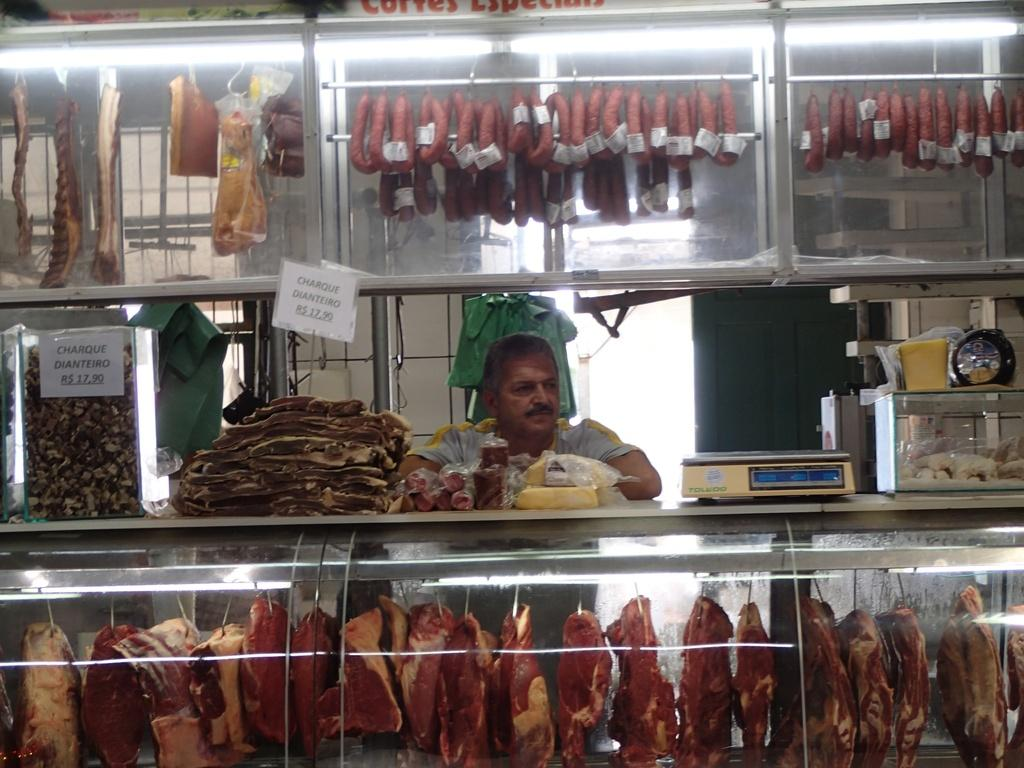Who or what is present in the image? There is a person in the image. What else can be seen in the image besides the person? There is a machine, glass boxes, lights, and meat in the image. Can you describe the machine in the image? The provided facts do not give a detailed description of the machine. What is the background of the image like? There is a wall in the background of the image. How does the person get to the farm in the image? There is no farm present in the image, so it is not possible to answer the question about getting there. 